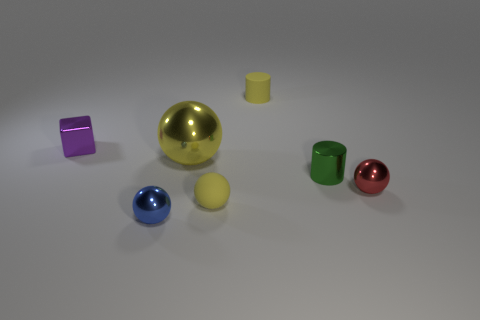The matte object that is the same color as the matte sphere is what shape?
Keep it short and to the point. Cylinder. Do the rubber thing in front of the big yellow metallic ball and the big yellow thing have the same shape?
Your answer should be compact. Yes. There is another ball that is the same color as the big shiny ball; what size is it?
Keep it short and to the point. Small. Is there a tiny rubber thing of the same color as the large object?
Provide a short and direct response. Yes. Is the shape of the red metallic object the same as the blue object?
Your answer should be compact. Yes. What is the tiny yellow object that is left of the yellow rubber cylinder made of?
Your answer should be compact. Rubber. The tiny metal cylinder has what color?
Make the answer very short. Green. There is a shiny object that is in front of the small red thing; is it the same size as the yellow ball that is on the left side of the yellow matte sphere?
Your answer should be compact. No. How big is the metallic ball that is behind the blue thing and on the left side of the metal cylinder?
Ensure brevity in your answer.  Large. There is another tiny metallic object that is the same shape as the blue shiny object; what is its color?
Your response must be concise. Red. 